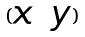<formula> <loc_0><loc_0><loc_500><loc_500>( \begin{matrix} x & y \end{matrix} )</formula> 